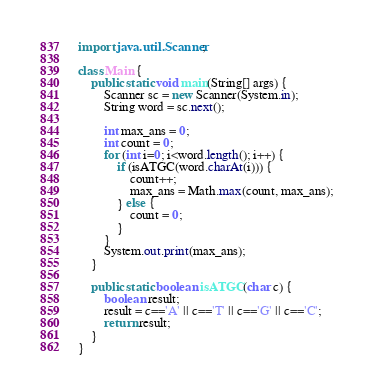<code> <loc_0><loc_0><loc_500><loc_500><_Java_>import java.util.Scanner;

class Main {
    public static void main(String[] args) {
        Scanner sc = new Scanner(System.in);
        String word = sc.next();

        int max_ans = 0;
        int count = 0;
        for (int i=0; i<word.length(); i++) {
            if (isATGC(word.charAt(i))) {
                count++;
                max_ans = Math.max(count, max_ans);
            } else {
                count = 0;
            }
        }
        System.out.print(max_ans);
    }

    public static boolean isATGC(char c) {
        boolean result;
        result = c=='A' || c=='T' || c=='G' || c=='C';
        return result;
    }
}</code> 